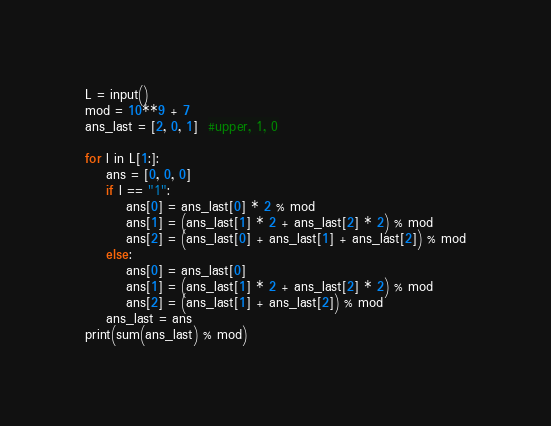<code> <loc_0><loc_0><loc_500><loc_500><_Python_>L = input()
mod = 10**9 + 7
ans_last = [2, 0, 1]  #upper, 1, 0

for l in L[1:]:
    ans = [0, 0, 0]
    if l == "1":
        ans[0] = ans_last[0] * 2 % mod
        ans[1] = (ans_last[1] * 2 + ans_last[2] * 2) % mod
        ans[2] = (ans_last[0] + ans_last[1] + ans_last[2]) % mod
    else:
        ans[0] = ans_last[0]
        ans[1] = (ans_last[1] * 2 + ans_last[2] * 2) % mod
        ans[2] = (ans_last[1] + ans_last[2]) % mod
    ans_last = ans
print(sum(ans_last) % mod)
</code> 